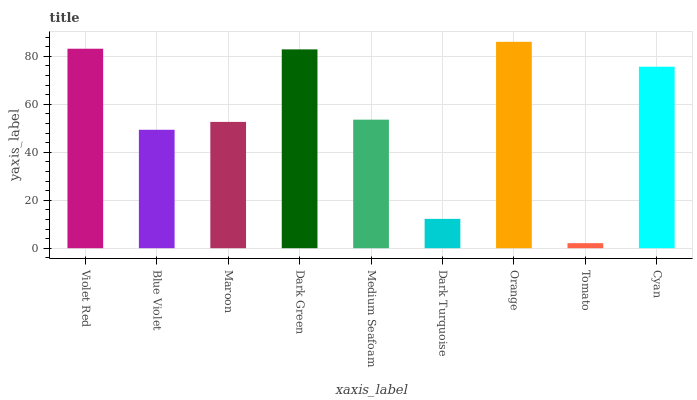Is Blue Violet the minimum?
Answer yes or no. No. Is Blue Violet the maximum?
Answer yes or no. No. Is Violet Red greater than Blue Violet?
Answer yes or no. Yes. Is Blue Violet less than Violet Red?
Answer yes or no. Yes. Is Blue Violet greater than Violet Red?
Answer yes or no. No. Is Violet Red less than Blue Violet?
Answer yes or no. No. Is Medium Seafoam the high median?
Answer yes or no. Yes. Is Medium Seafoam the low median?
Answer yes or no. Yes. Is Dark Green the high median?
Answer yes or no. No. Is Tomato the low median?
Answer yes or no. No. 